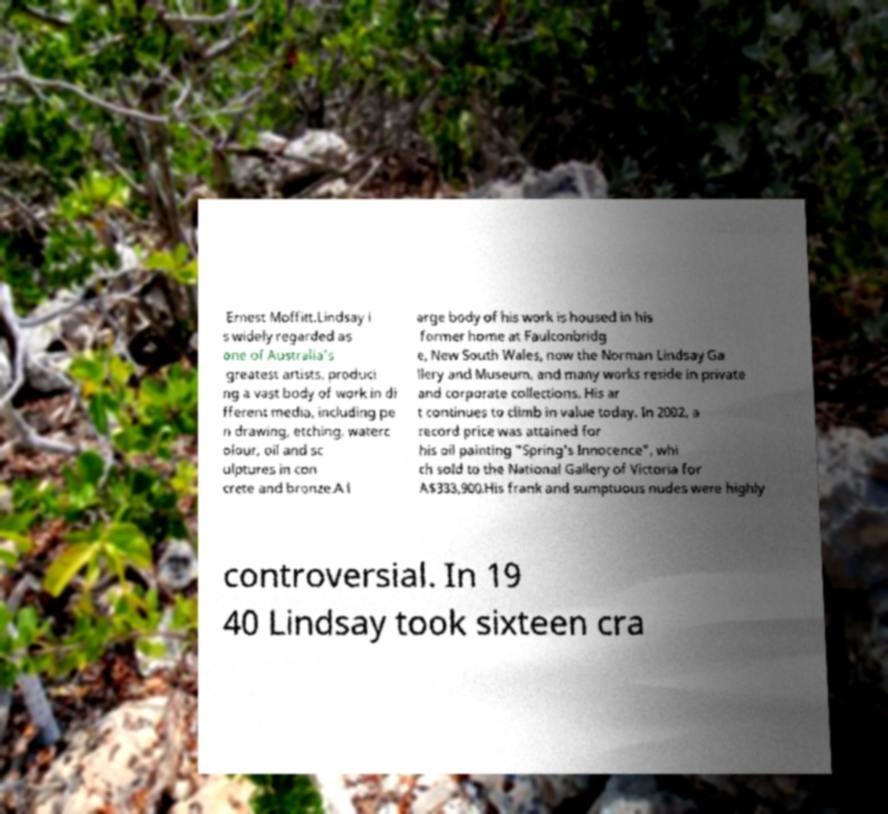Please identify and transcribe the text found in this image. Ernest Moffitt.Lindsay i s widely regarded as one of Australia's greatest artists, produci ng a vast body of work in di fferent media, including pe n drawing, etching, waterc olour, oil and sc ulptures in con crete and bronze.A l arge body of his work is housed in his former home at Faulconbridg e, New South Wales, now the Norman Lindsay Ga llery and Museum, and many works reside in private and corporate collections. His ar t continues to climb in value today. In 2002, a record price was attained for his oil painting "Spring's Innocence", whi ch sold to the National Gallery of Victoria for A$333,900.His frank and sumptuous nudes were highly controversial. In 19 40 Lindsay took sixteen cra 